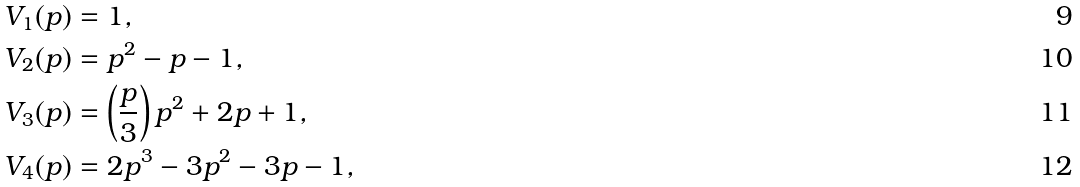Convert formula to latex. <formula><loc_0><loc_0><loc_500><loc_500>& V _ { 1 } ( p ) = 1 , \\ & V _ { 2 } ( p ) = p ^ { 2 } - p - 1 , \\ & V _ { 3 } ( p ) = \left ( \frac { p } { 3 } \right ) p ^ { 2 } + 2 p + 1 , \\ & V _ { 4 } ( p ) = 2 p ^ { 3 } - 3 p ^ { 2 } - 3 p - 1 ,</formula> 